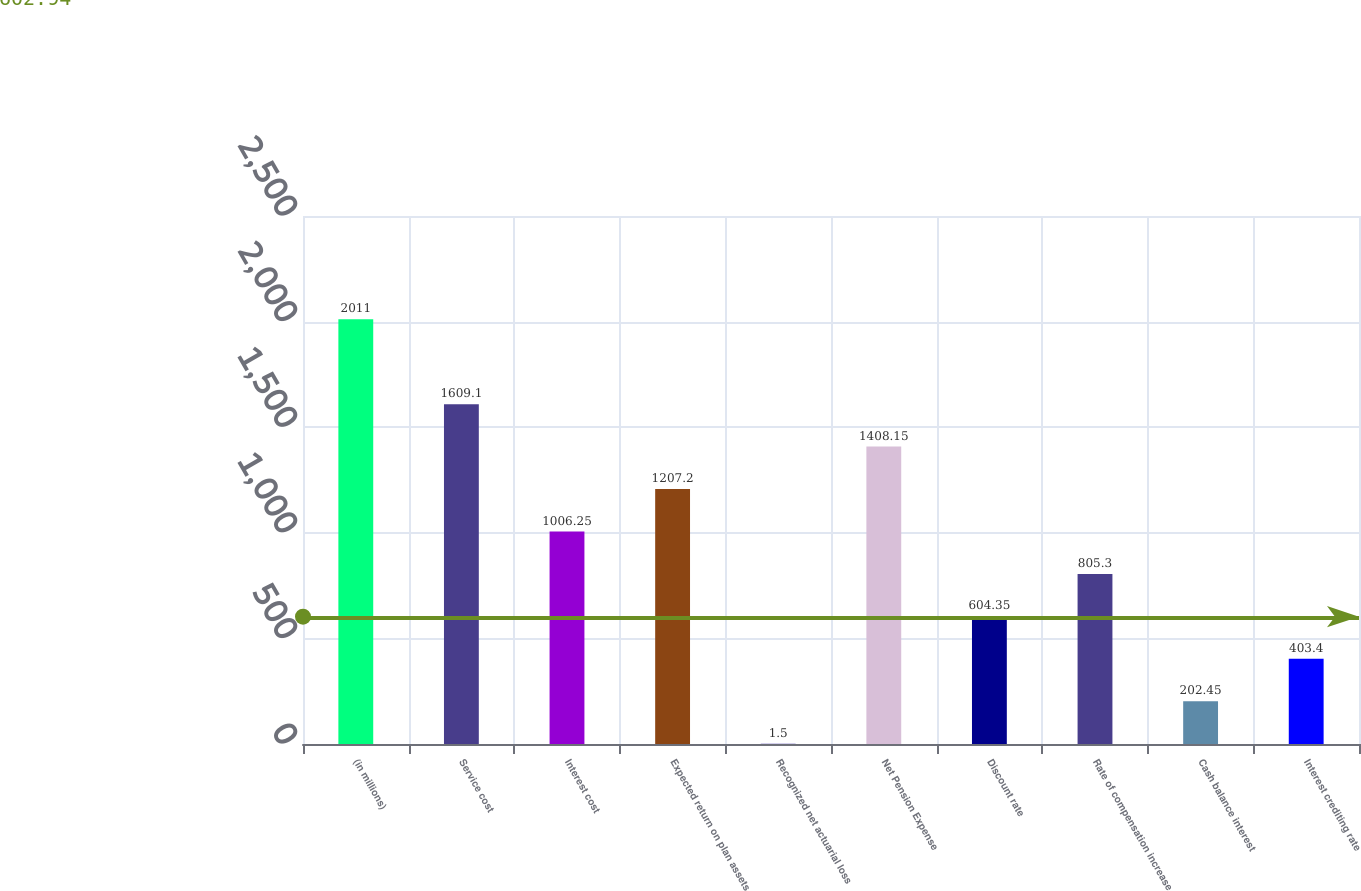Convert chart. <chart><loc_0><loc_0><loc_500><loc_500><bar_chart><fcel>(in millions)<fcel>Service cost<fcel>Interest cost<fcel>Expected return on plan assets<fcel>Recognized net actuarial loss<fcel>Net Pension Expense<fcel>Discount rate<fcel>Rate of compensation increase<fcel>Cash balance interest<fcel>Interest crediting rate<nl><fcel>2011<fcel>1609.1<fcel>1006.25<fcel>1207.2<fcel>1.5<fcel>1408.15<fcel>604.35<fcel>805.3<fcel>202.45<fcel>403.4<nl></chart> 